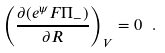<formula> <loc_0><loc_0><loc_500><loc_500>\left ( \frac { \partial ( e ^ { \psi } F \Pi _ { - } ) } { \partial R } \right ) _ { V } = 0 \ .</formula> 